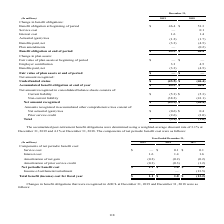According to Sealed Air Corporation's financial document, What employees are eligible for two Other Post-Employment Benefit Plans? Based on the financial document, the answer is Covered employees who retired on or after attaining age 55 and who had rendered at least 10 years of service. Also, What years are included in the table? The document shows two values: 2019 and 2018. From the document: "(In millions) 2019 2018 (In millions) 2019 2018..." Also, What does the table represent? Based on the financial document, the answer is Contributions made by us, net of Medicare Part D subsidies received in the U.S., are reported below as benefits paid. We may change the benefits at any time. The status of these plans, including a reconciliation of benefit obligations, a reconciliation of plan assets and the funded status of the plans. Also, can you calculate: How much more Net actuarial gain is there in 2019 than 2018? Based on the calculation: -0.6-0.4, the result is -1 (in millions). This is based on the information: "Net actuarial (gain) loss $ (0.6) $ 0.4 Net actuarial (gain) loss $ (0.6) $ 0.4..." The key data points involved are: 0.4, 0.6. Also, can you calculate: What is the difference between Benefit obligation at beginning of period for 2018 and 2019? Based on the calculation: 51.3-46.4, the result is 4.9 (in millions). This is based on the information: "enefit obligation at beginning of period $ 46.4 $ 51.3 Benefit obligation at beginning of period $ 46.4 $ 51.3..." The key data points involved are: 46.4, 51.3. Also, can you calculate: What is Benefit obligation at end of period expressed as a percentage of Benefit obligation at beginning of period for 2019? Based on the calculation: 43.5/46.4, the result is 93.75 (percentage). This is based on the information: "nts — (0.2) Benefit obligation at end of period $ 43.5 $ 46.4 0.2) Benefit obligation at end of period $ 43.5 $ 46.4..." The key data points involved are: 43.5, 46.4. 